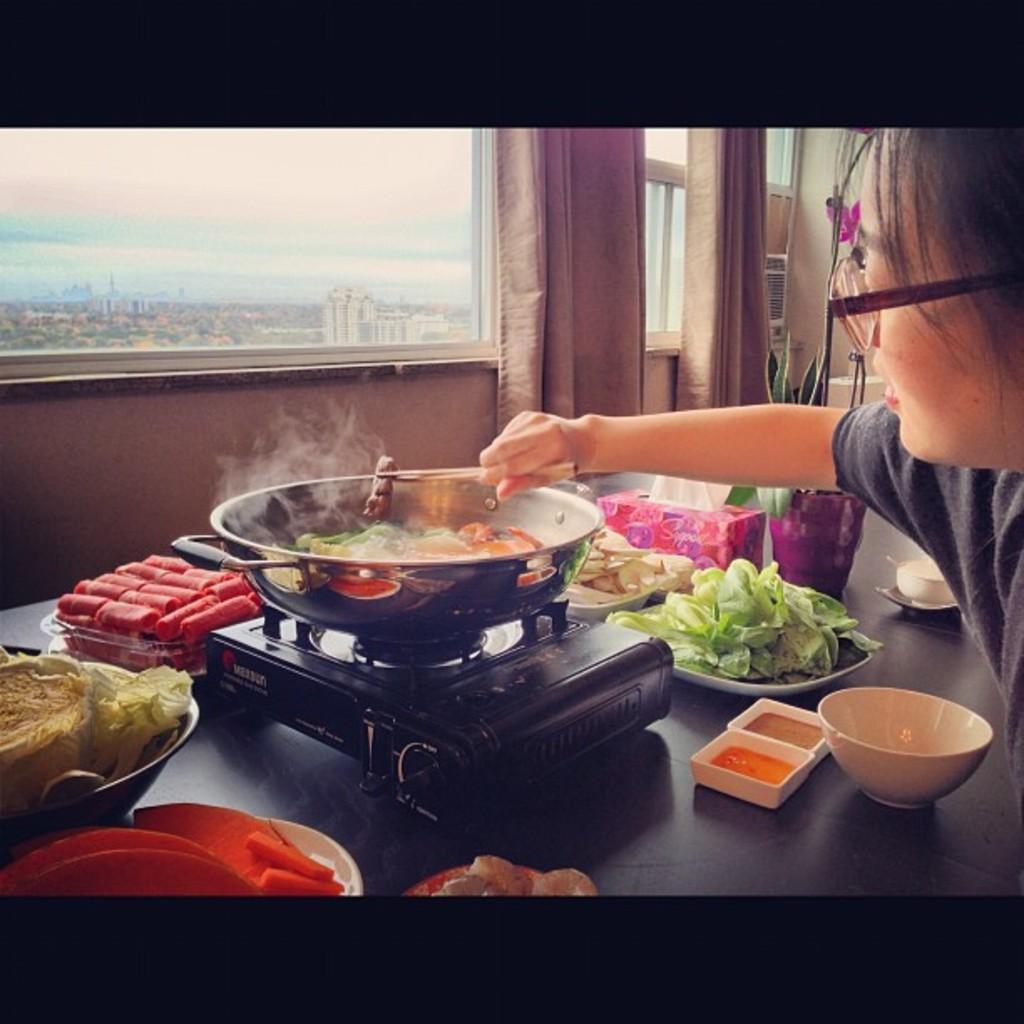Describe this image in one or two sentences. In this picture there is a table in the center of the image, which contains food items and a stove on it, there is a lady on the right side of the image and there are windows at the top side of the image. 